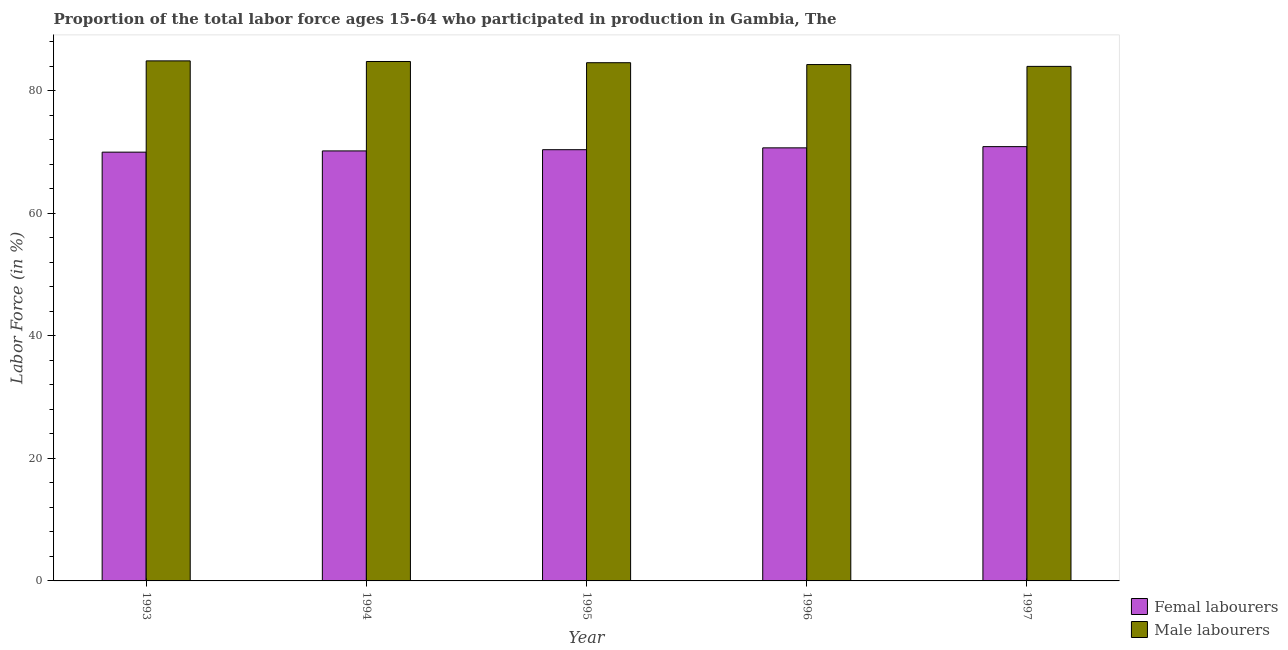How many different coloured bars are there?
Provide a succinct answer. 2. How many groups of bars are there?
Your answer should be compact. 5. Are the number of bars on each tick of the X-axis equal?
Your response must be concise. Yes. How many bars are there on the 4th tick from the right?
Provide a short and direct response. 2. In how many cases, is the number of bars for a given year not equal to the number of legend labels?
Provide a succinct answer. 0. What is the percentage of male labour force in 1995?
Keep it short and to the point. 84.6. Across all years, what is the maximum percentage of male labour force?
Keep it short and to the point. 84.9. In which year was the percentage of male labour force minimum?
Your answer should be compact. 1997. What is the total percentage of male labour force in the graph?
Your answer should be compact. 422.6. What is the difference between the percentage of male labour force in 1995 and that in 1997?
Make the answer very short. 0.6. What is the difference between the percentage of male labour force in 1993 and the percentage of female labor force in 1995?
Keep it short and to the point. 0.3. What is the average percentage of male labour force per year?
Keep it short and to the point. 84.52. What is the ratio of the percentage of female labor force in 1993 to that in 1994?
Provide a short and direct response. 1. Is the difference between the percentage of male labour force in 1994 and 1995 greater than the difference between the percentage of female labor force in 1994 and 1995?
Keep it short and to the point. No. What is the difference between the highest and the second highest percentage of male labour force?
Your answer should be compact. 0.1. What is the difference between the highest and the lowest percentage of male labour force?
Keep it short and to the point. 0.9. Is the sum of the percentage of female labor force in 1993 and 1994 greater than the maximum percentage of male labour force across all years?
Your response must be concise. Yes. What does the 2nd bar from the left in 1997 represents?
Ensure brevity in your answer.  Male labourers. What does the 1st bar from the right in 1996 represents?
Make the answer very short. Male labourers. What is the difference between two consecutive major ticks on the Y-axis?
Provide a short and direct response. 20. Are the values on the major ticks of Y-axis written in scientific E-notation?
Your response must be concise. No. Does the graph contain grids?
Offer a terse response. No. What is the title of the graph?
Provide a short and direct response. Proportion of the total labor force ages 15-64 who participated in production in Gambia, The. What is the Labor Force (in %) in Male labourers in 1993?
Offer a terse response. 84.9. What is the Labor Force (in %) in Femal labourers in 1994?
Your response must be concise. 70.2. What is the Labor Force (in %) of Male labourers in 1994?
Make the answer very short. 84.8. What is the Labor Force (in %) of Femal labourers in 1995?
Give a very brief answer. 70.4. What is the Labor Force (in %) in Male labourers in 1995?
Keep it short and to the point. 84.6. What is the Labor Force (in %) of Femal labourers in 1996?
Offer a very short reply. 70.7. What is the Labor Force (in %) of Male labourers in 1996?
Provide a short and direct response. 84.3. What is the Labor Force (in %) in Femal labourers in 1997?
Offer a terse response. 70.9. What is the Labor Force (in %) of Male labourers in 1997?
Offer a terse response. 84. Across all years, what is the maximum Labor Force (in %) in Femal labourers?
Make the answer very short. 70.9. Across all years, what is the maximum Labor Force (in %) of Male labourers?
Give a very brief answer. 84.9. Across all years, what is the minimum Labor Force (in %) of Femal labourers?
Ensure brevity in your answer.  70. Across all years, what is the minimum Labor Force (in %) of Male labourers?
Your response must be concise. 84. What is the total Labor Force (in %) in Femal labourers in the graph?
Your answer should be very brief. 352.2. What is the total Labor Force (in %) of Male labourers in the graph?
Your answer should be compact. 422.6. What is the difference between the Labor Force (in %) of Male labourers in 1993 and that in 1994?
Provide a succinct answer. 0.1. What is the difference between the Labor Force (in %) in Femal labourers in 1993 and that in 1995?
Offer a very short reply. -0.4. What is the difference between the Labor Force (in %) in Male labourers in 1993 and that in 1996?
Keep it short and to the point. 0.6. What is the difference between the Labor Force (in %) in Femal labourers in 1993 and that in 1997?
Keep it short and to the point. -0.9. What is the difference between the Labor Force (in %) in Male labourers in 1993 and that in 1997?
Provide a short and direct response. 0.9. What is the difference between the Labor Force (in %) in Femal labourers in 1994 and that in 1995?
Give a very brief answer. -0.2. What is the difference between the Labor Force (in %) of Male labourers in 1994 and that in 1995?
Provide a short and direct response. 0.2. What is the difference between the Labor Force (in %) in Male labourers in 1994 and that in 1996?
Give a very brief answer. 0.5. What is the difference between the Labor Force (in %) of Femal labourers in 1994 and that in 1997?
Give a very brief answer. -0.7. What is the difference between the Labor Force (in %) of Male labourers in 1994 and that in 1997?
Provide a succinct answer. 0.8. What is the difference between the Labor Force (in %) of Male labourers in 1995 and that in 1996?
Give a very brief answer. 0.3. What is the difference between the Labor Force (in %) of Femal labourers in 1995 and that in 1997?
Offer a very short reply. -0.5. What is the difference between the Labor Force (in %) in Male labourers in 1996 and that in 1997?
Offer a very short reply. 0.3. What is the difference between the Labor Force (in %) of Femal labourers in 1993 and the Labor Force (in %) of Male labourers in 1994?
Keep it short and to the point. -14.8. What is the difference between the Labor Force (in %) of Femal labourers in 1993 and the Labor Force (in %) of Male labourers in 1995?
Offer a very short reply. -14.6. What is the difference between the Labor Force (in %) of Femal labourers in 1993 and the Labor Force (in %) of Male labourers in 1996?
Give a very brief answer. -14.3. What is the difference between the Labor Force (in %) in Femal labourers in 1993 and the Labor Force (in %) in Male labourers in 1997?
Your response must be concise. -14. What is the difference between the Labor Force (in %) in Femal labourers in 1994 and the Labor Force (in %) in Male labourers in 1995?
Make the answer very short. -14.4. What is the difference between the Labor Force (in %) of Femal labourers in 1994 and the Labor Force (in %) of Male labourers in 1996?
Your answer should be compact. -14.1. What is the difference between the Labor Force (in %) in Femal labourers in 1994 and the Labor Force (in %) in Male labourers in 1997?
Ensure brevity in your answer.  -13.8. What is the difference between the Labor Force (in %) in Femal labourers in 1995 and the Labor Force (in %) in Male labourers in 1997?
Keep it short and to the point. -13.6. What is the difference between the Labor Force (in %) of Femal labourers in 1996 and the Labor Force (in %) of Male labourers in 1997?
Your answer should be very brief. -13.3. What is the average Labor Force (in %) in Femal labourers per year?
Your response must be concise. 70.44. What is the average Labor Force (in %) in Male labourers per year?
Keep it short and to the point. 84.52. In the year 1993, what is the difference between the Labor Force (in %) in Femal labourers and Labor Force (in %) in Male labourers?
Keep it short and to the point. -14.9. In the year 1994, what is the difference between the Labor Force (in %) in Femal labourers and Labor Force (in %) in Male labourers?
Your response must be concise. -14.6. In the year 1995, what is the difference between the Labor Force (in %) of Femal labourers and Labor Force (in %) of Male labourers?
Offer a terse response. -14.2. In the year 1996, what is the difference between the Labor Force (in %) in Femal labourers and Labor Force (in %) in Male labourers?
Give a very brief answer. -13.6. In the year 1997, what is the difference between the Labor Force (in %) in Femal labourers and Labor Force (in %) in Male labourers?
Your answer should be compact. -13.1. What is the ratio of the Labor Force (in %) of Femal labourers in 1993 to that in 1995?
Your response must be concise. 0.99. What is the ratio of the Labor Force (in %) of Femal labourers in 1993 to that in 1996?
Provide a short and direct response. 0.99. What is the ratio of the Labor Force (in %) of Male labourers in 1993 to that in 1996?
Provide a succinct answer. 1.01. What is the ratio of the Labor Force (in %) of Femal labourers in 1993 to that in 1997?
Your answer should be very brief. 0.99. What is the ratio of the Labor Force (in %) in Male labourers in 1993 to that in 1997?
Your answer should be compact. 1.01. What is the ratio of the Labor Force (in %) of Femal labourers in 1994 to that in 1995?
Make the answer very short. 1. What is the ratio of the Labor Force (in %) of Femal labourers in 1994 to that in 1996?
Provide a succinct answer. 0.99. What is the ratio of the Labor Force (in %) of Male labourers in 1994 to that in 1996?
Provide a succinct answer. 1.01. What is the ratio of the Labor Force (in %) in Male labourers in 1994 to that in 1997?
Make the answer very short. 1.01. What is the ratio of the Labor Force (in %) of Femal labourers in 1995 to that in 1997?
Your response must be concise. 0.99. What is the ratio of the Labor Force (in %) in Male labourers in 1995 to that in 1997?
Offer a very short reply. 1.01. What is the ratio of the Labor Force (in %) in Male labourers in 1996 to that in 1997?
Keep it short and to the point. 1. What is the difference between the highest and the second highest Labor Force (in %) of Femal labourers?
Offer a very short reply. 0.2. What is the difference between the highest and the lowest Labor Force (in %) in Femal labourers?
Your answer should be very brief. 0.9. What is the difference between the highest and the lowest Labor Force (in %) in Male labourers?
Give a very brief answer. 0.9. 